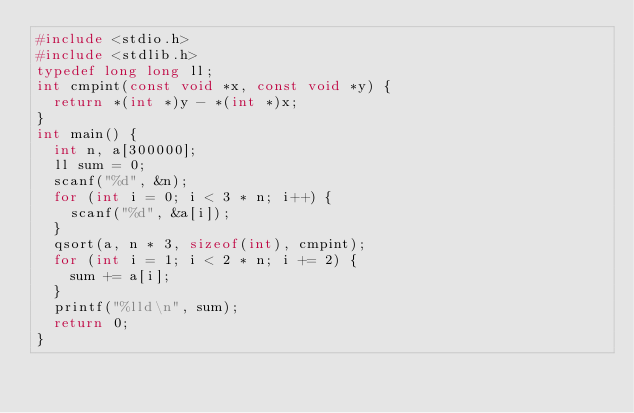Convert code to text. <code><loc_0><loc_0><loc_500><loc_500><_C_>#include <stdio.h>
#include <stdlib.h>
typedef long long ll;
int cmpint(const void *x, const void *y) {
	return *(int *)y - *(int *)x;
}
int main() {
	int n, a[300000];
	ll sum = 0;
	scanf("%d", &n);
	for (int i = 0; i < 3 * n; i++) {
		scanf("%d", &a[i]);
	}
	qsort(a, n * 3, sizeof(int), cmpint);
	for (int i = 1; i < 2 * n; i += 2) {
		sum += a[i];
	}
	printf("%lld\n", sum);
	return 0;
}</code> 